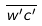Convert formula to latex. <formula><loc_0><loc_0><loc_500><loc_500>\overline { w ^ { \prime } c ^ { \prime } }</formula> 